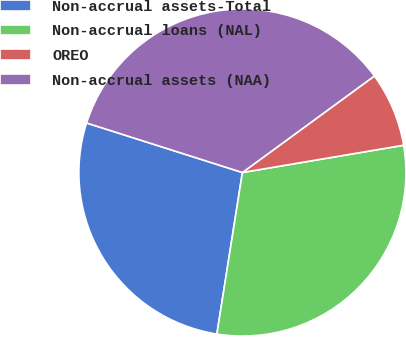<chart> <loc_0><loc_0><loc_500><loc_500><pie_chart><fcel>Non-accrual assets-Total<fcel>Non-accrual loans (NAL)<fcel>OREO<fcel>Non-accrual assets (NAA)<nl><fcel>27.4%<fcel>30.16%<fcel>7.38%<fcel>35.05%<nl></chart> 